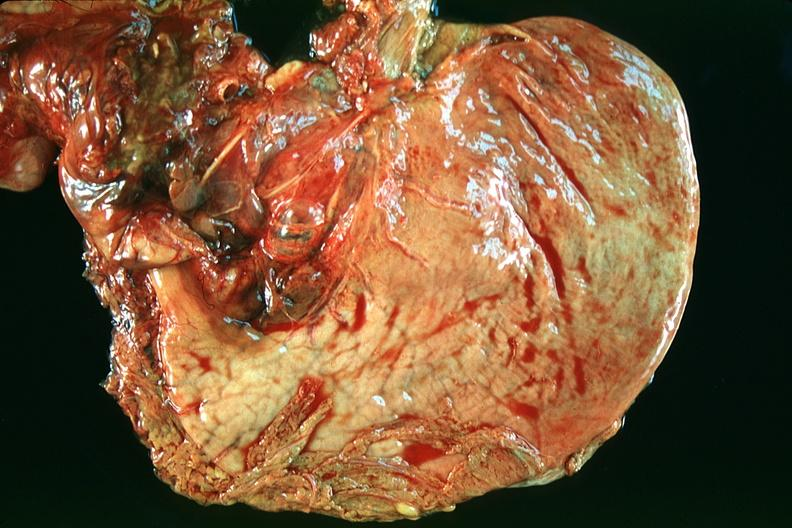s gastrointestinal present?
Answer the question using a single word or phrase. Yes 